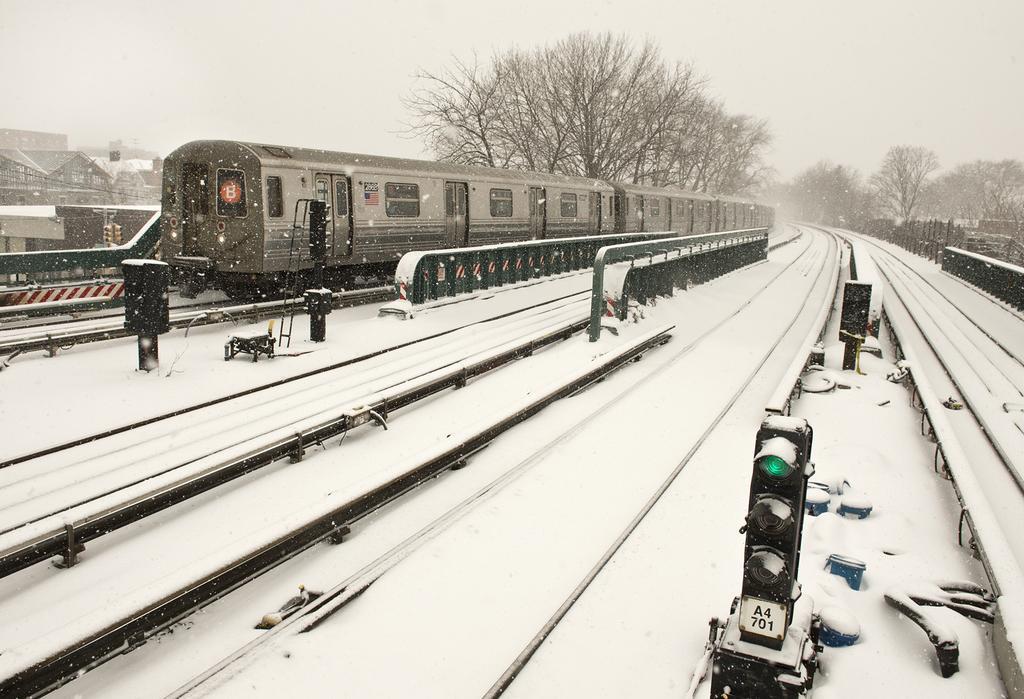Could you give a brief overview of what you see in this image? Here in this picture we can see railway tracks and signal lights present all over there and they are covered with snow and we can also see a train present on the track over there and behind that we can see houses and buildings present and we can see trees here and there over the place. 